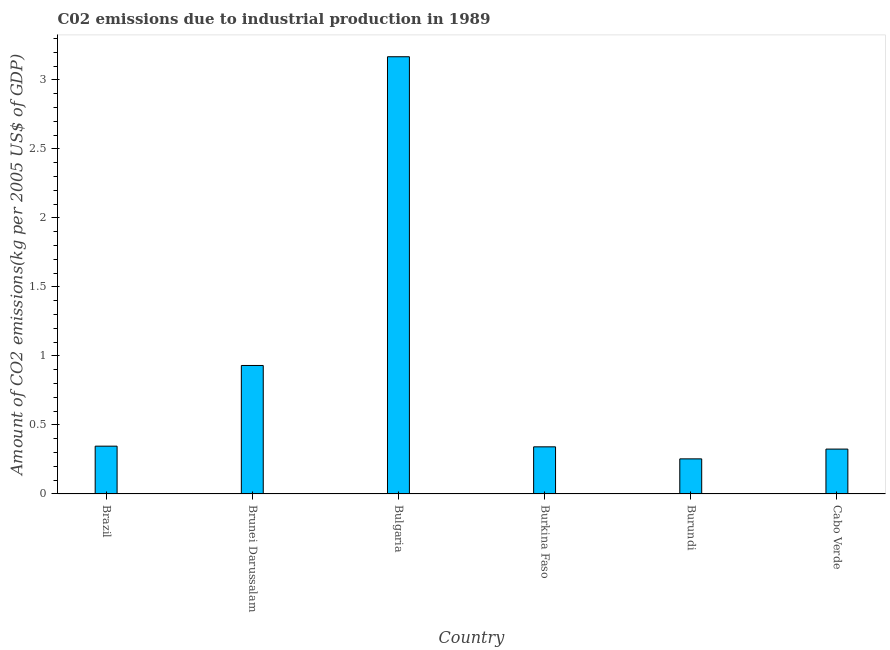Does the graph contain any zero values?
Provide a short and direct response. No. What is the title of the graph?
Your answer should be compact. C02 emissions due to industrial production in 1989. What is the label or title of the Y-axis?
Offer a very short reply. Amount of CO2 emissions(kg per 2005 US$ of GDP). What is the amount of co2 emissions in Brunei Darussalam?
Make the answer very short. 0.93. Across all countries, what is the maximum amount of co2 emissions?
Offer a very short reply. 3.17. Across all countries, what is the minimum amount of co2 emissions?
Provide a short and direct response. 0.25. In which country was the amount of co2 emissions maximum?
Your answer should be very brief. Bulgaria. In which country was the amount of co2 emissions minimum?
Offer a terse response. Burundi. What is the sum of the amount of co2 emissions?
Provide a short and direct response. 5.37. What is the difference between the amount of co2 emissions in Bulgaria and Burundi?
Provide a short and direct response. 2.91. What is the average amount of co2 emissions per country?
Provide a short and direct response. 0.89. What is the median amount of co2 emissions?
Ensure brevity in your answer.  0.34. In how many countries, is the amount of co2 emissions greater than 0.3 kg per 2005 US$ of GDP?
Provide a succinct answer. 5. What is the ratio of the amount of co2 emissions in Burundi to that in Cabo Verde?
Give a very brief answer. 0.78. Is the amount of co2 emissions in Bulgaria less than that in Cabo Verde?
Your response must be concise. No. Is the difference between the amount of co2 emissions in Brunei Darussalam and Burkina Faso greater than the difference between any two countries?
Keep it short and to the point. No. What is the difference between the highest and the second highest amount of co2 emissions?
Keep it short and to the point. 2.24. Is the sum of the amount of co2 emissions in Bulgaria and Cabo Verde greater than the maximum amount of co2 emissions across all countries?
Keep it short and to the point. Yes. What is the difference between the highest and the lowest amount of co2 emissions?
Your answer should be compact. 2.91. In how many countries, is the amount of co2 emissions greater than the average amount of co2 emissions taken over all countries?
Your answer should be compact. 2. How many bars are there?
Provide a succinct answer. 6. Are all the bars in the graph horizontal?
Provide a short and direct response. No. How many countries are there in the graph?
Provide a short and direct response. 6. What is the difference between two consecutive major ticks on the Y-axis?
Your answer should be very brief. 0.5. Are the values on the major ticks of Y-axis written in scientific E-notation?
Ensure brevity in your answer.  No. What is the Amount of CO2 emissions(kg per 2005 US$ of GDP) of Brazil?
Give a very brief answer. 0.35. What is the Amount of CO2 emissions(kg per 2005 US$ of GDP) in Brunei Darussalam?
Offer a terse response. 0.93. What is the Amount of CO2 emissions(kg per 2005 US$ of GDP) of Bulgaria?
Your response must be concise. 3.17. What is the Amount of CO2 emissions(kg per 2005 US$ of GDP) in Burkina Faso?
Make the answer very short. 0.34. What is the Amount of CO2 emissions(kg per 2005 US$ of GDP) in Burundi?
Ensure brevity in your answer.  0.25. What is the Amount of CO2 emissions(kg per 2005 US$ of GDP) in Cabo Verde?
Make the answer very short. 0.33. What is the difference between the Amount of CO2 emissions(kg per 2005 US$ of GDP) in Brazil and Brunei Darussalam?
Provide a short and direct response. -0.58. What is the difference between the Amount of CO2 emissions(kg per 2005 US$ of GDP) in Brazil and Bulgaria?
Offer a very short reply. -2.82. What is the difference between the Amount of CO2 emissions(kg per 2005 US$ of GDP) in Brazil and Burkina Faso?
Offer a very short reply. 0. What is the difference between the Amount of CO2 emissions(kg per 2005 US$ of GDP) in Brazil and Burundi?
Offer a very short reply. 0.09. What is the difference between the Amount of CO2 emissions(kg per 2005 US$ of GDP) in Brazil and Cabo Verde?
Provide a succinct answer. 0.02. What is the difference between the Amount of CO2 emissions(kg per 2005 US$ of GDP) in Brunei Darussalam and Bulgaria?
Your response must be concise. -2.24. What is the difference between the Amount of CO2 emissions(kg per 2005 US$ of GDP) in Brunei Darussalam and Burkina Faso?
Make the answer very short. 0.59. What is the difference between the Amount of CO2 emissions(kg per 2005 US$ of GDP) in Brunei Darussalam and Burundi?
Offer a terse response. 0.68. What is the difference between the Amount of CO2 emissions(kg per 2005 US$ of GDP) in Brunei Darussalam and Cabo Verde?
Give a very brief answer. 0.61. What is the difference between the Amount of CO2 emissions(kg per 2005 US$ of GDP) in Bulgaria and Burkina Faso?
Give a very brief answer. 2.83. What is the difference between the Amount of CO2 emissions(kg per 2005 US$ of GDP) in Bulgaria and Burundi?
Ensure brevity in your answer.  2.91. What is the difference between the Amount of CO2 emissions(kg per 2005 US$ of GDP) in Bulgaria and Cabo Verde?
Make the answer very short. 2.84. What is the difference between the Amount of CO2 emissions(kg per 2005 US$ of GDP) in Burkina Faso and Burundi?
Give a very brief answer. 0.09. What is the difference between the Amount of CO2 emissions(kg per 2005 US$ of GDP) in Burkina Faso and Cabo Verde?
Make the answer very short. 0.02. What is the difference between the Amount of CO2 emissions(kg per 2005 US$ of GDP) in Burundi and Cabo Verde?
Provide a succinct answer. -0.07. What is the ratio of the Amount of CO2 emissions(kg per 2005 US$ of GDP) in Brazil to that in Brunei Darussalam?
Your response must be concise. 0.37. What is the ratio of the Amount of CO2 emissions(kg per 2005 US$ of GDP) in Brazil to that in Bulgaria?
Make the answer very short. 0.11. What is the ratio of the Amount of CO2 emissions(kg per 2005 US$ of GDP) in Brazil to that in Burundi?
Provide a succinct answer. 1.36. What is the ratio of the Amount of CO2 emissions(kg per 2005 US$ of GDP) in Brazil to that in Cabo Verde?
Give a very brief answer. 1.06. What is the ratio of the Amount of CO2 emissions(kg per 2005 US$ of GDP) in Brunei Darussalam to that in Bulgaria?
Ensure brevity in your answer.  0.29. What is the ratio of the Amount of CO2 emissions(kg per 2005 US$ of GDP) in Brunei Darussalam to that in Burkina Faso?
Ensure brevity in your answer.  2.73. What is the ratio of the Amount of CO2 emissions(kg per 2005 US$ of GDP) in Brunei Darussalam to that in Burundi?
Your answer should be very brief. 3.66. What is the ratio of the Amount of CO2 emissions(kg per 2005 US$ of GDP) in Brunei Darussalam to that in Cabo Verde?
Ensure brevity in your answer.  2.86. What is the ratio of the Amount of CO2 emissions(kg per 2005 US$ of GDP) in Bulgaria to that in Burkina Faso?
Give a very brief answer. 9.28. What is the ratio of the Amount of CO2 emissions(kg per 2005 US$ of GDP) in Bulgaria to that in Burundi?
Provide a short and direct response. 12.46. What is the ratio of the Amount of CO2 emissions(kg per 2005 US$ of GDP) in Bulgaria to that in Cabo Verde?
Offer a terse response. 9.74. What is the ratio of the Amount of CO2 emissions(kg per 2005 US$ of GDP) in Burkina Faso to that in Burundi?
Your answer should be very brief. 1.34. What is the ratio of the Amount of CO2 emissions(kg per 2005 US$ of GDP) in Burundi to that in Cabo Verde?
Your answer should be very brief. 0.78. 